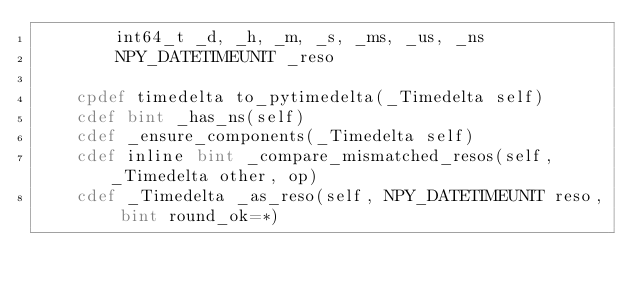<code> <loc_0><loc_0><loc_500><loc_500><_Cython_>        int64_t _d, _h, _m, _s, _ms, _us, _ns
        NPY_DATETIMEUNIT _reso

    cpdef timedelta to_pytimedelta(_Timedelta self)
    cdef bint _has_ns(self)
    cdef _ensure_components(_Timedelta self)
    cdef inline bint _compare_mismatched_resos(self, _Timedelta other, op)
    cdef _Timedelta _as_reso(self, NPY_DATETIMEUNIT reso, bint round_ok=*)
</code> 